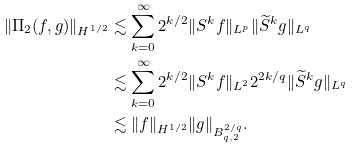<formula> <loc_0><loc_0><loc_500><loc_500>\| \Pi _ { 2 } ( f , g ) \| _ { H ^ { 1 / 2 } } & \lesssim \sum _ { k = 0 } ^ { \infty } 2 ^ { k / 2 } \| S ^ { k } f \| _ { L ^ { p } } \| \widetilde { S } ^ { k } g \| _ { L ^ { q } } \\ & \lesssim \sum _ { k = 0 } ^ { \infty } 2 ^ { k / 2 } \| S ^ { k } f \| _ { L ^ { 2 } } 2 ^ { 2 k / q } \| \widetilde { S } ^ { k } g \| _ { L ^ { q } } \\ & \lesssim \| f \| _ { H ^ { 1 / 2 } } \| g \| _ { B ^ { 2 / q } _ { q , 2 } } .</formula> 